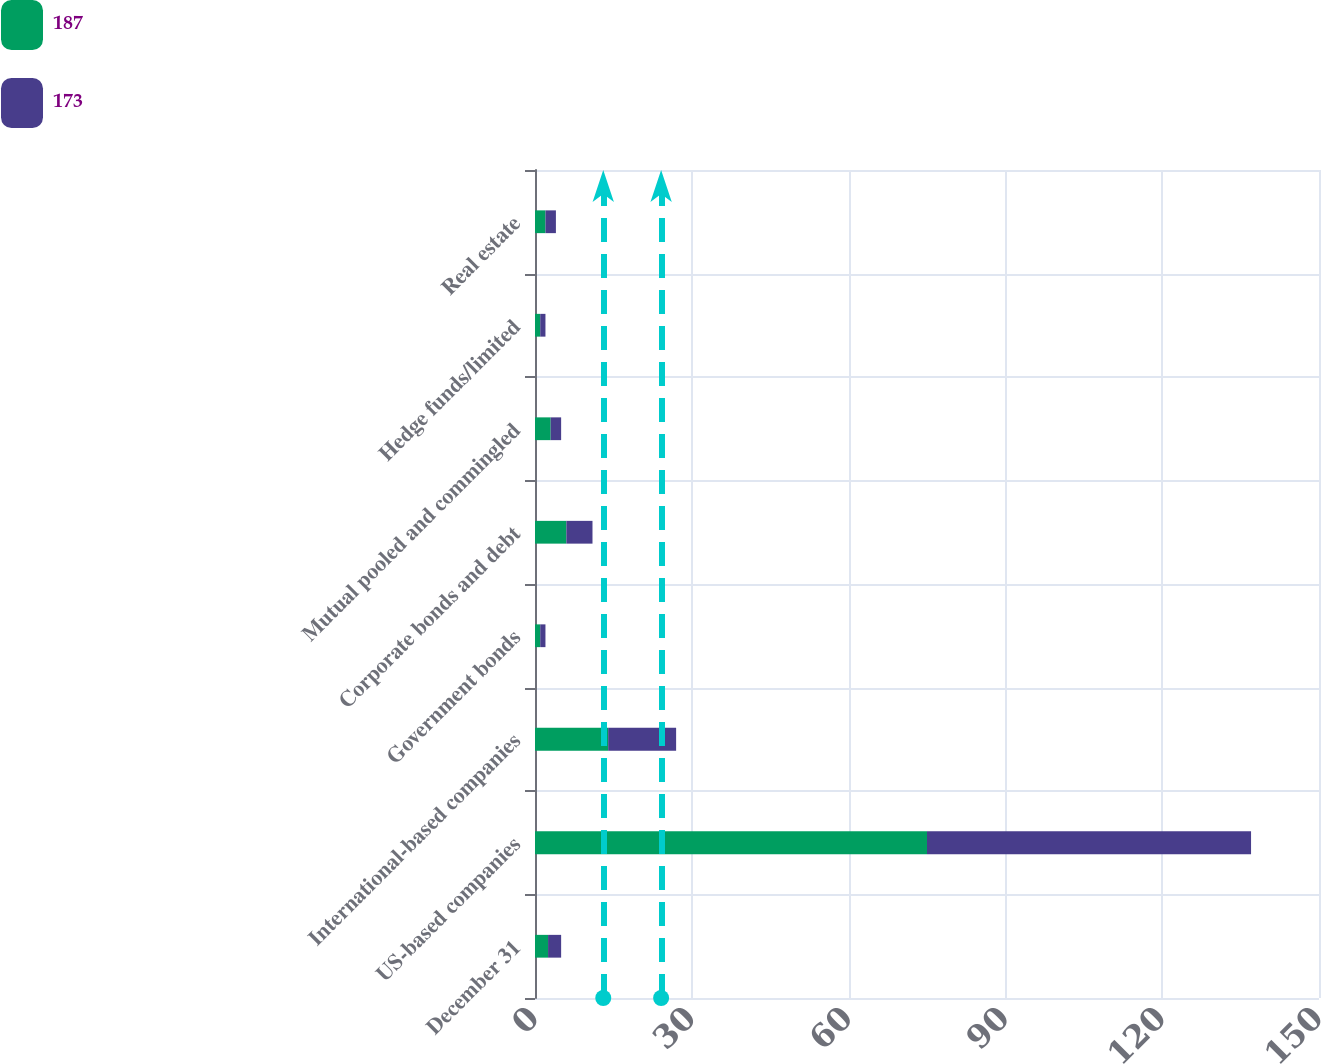<chart> <loc_0><loc_0><loc_500><loc_500><stacked_bar_chart><ecel><fcel>December 31<fcel>US-based companies<fcel>International-based companies<fcel>Government bonds<fcel>Corporate bonds and debt<fcel>Mutual pooled and commingled<fcel>Hedge funds/limited<fcel>Real estate<nl><fcel>187<fcel>2.5<fcel>75<fcel>14<fcel>1<fcel>6<fcel>3<fcel>1<fcel>2<nl><fcel>173<fcel>2.5<fcel>62<fcel>13<fcel>1<fcel>5<fcel>2<fcel>1<fcel>2<nl></chart> 